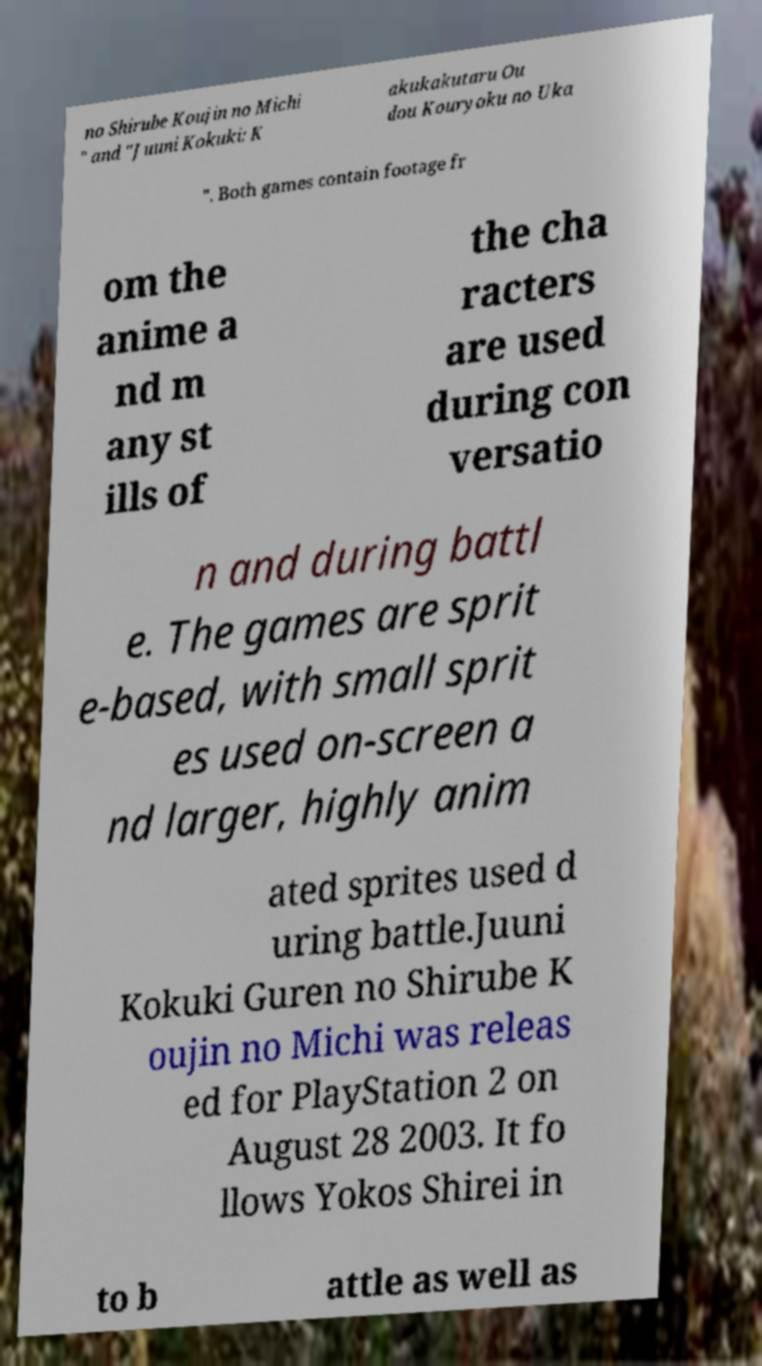Please read and relay the text visible in this image. What does it say? no Shirube Koujin no Michi " and "Juuni Kokuki: K akukakutaru Ou dou Kouryoku no Uka ". Both games contain footage fr om the anime a nd m any st ills of the cha racters are used during con versatio n and during battl e. The games are sprit e-based, with small sprit es used on-screen a nd larger, highly anim ated sprites used d uring battle.Juuni Kokuki Guren no Shirube K oujin no Michi was releas ed for PlayStation 2 on August 28 2003. It fo llows Yokos Shirei in to b attle as well as 